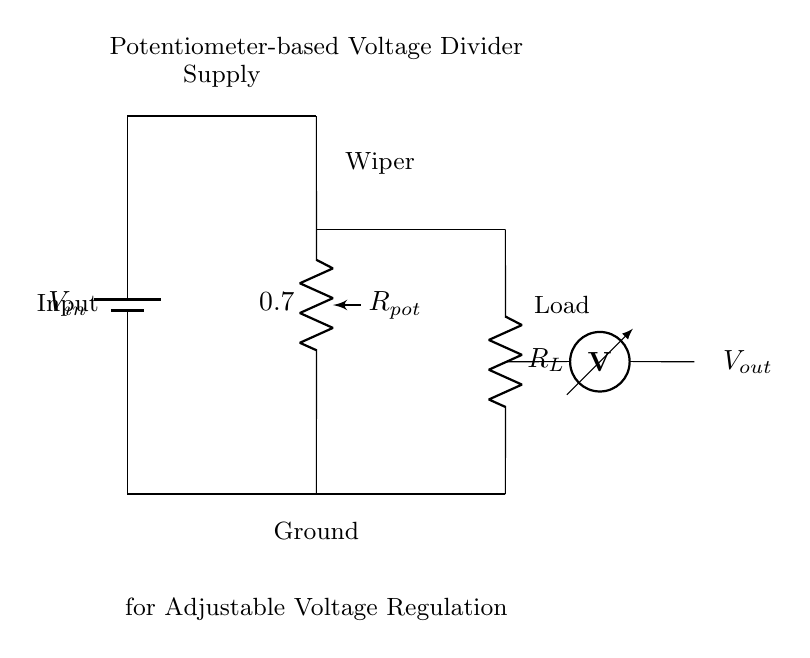What is the type of input in this circuit? The input in this circuit is a battery, indicated by the "battery1" symbol. It provides the voltage supply for the circuit.
Answer: Battery What is the purpose of the potentiometer in this circuit? The potentiometer is used as a variable resistor to adjust the voltage divided between its two ends, allowing for adjustable output voltage.
Answer: Adjustable voltage What is connected to the output of the circuit? The output of the circuit connects to a resistor labeled as "R_L", indicating it supplies voltage to a load.
Answer: R_L What happens to the output voltage if the potentiometer wiper is moved towards the top? Moving the wiper towards the top increases the output voltage as a greater portion of the input voltage appears across the load.
Answer: Increases What is the role of R_L in this circuit? R_L serves as the load resistance and it draws current from the voltage divider circuit, influencing the output voltage based on its value.
Answer: Load resistance What is the output voltage in relation to the input voltage? The output voltage is a fraction of the input voltage determined by the ratio of the potentiometer's resistance to the total resistance in the circuit.
Answer: Fraction What type of circuit is represented here? This is a voltage divider circuit specifically utilizing a potentiometer for adjustable voltage regulation.
Answer: Voltage divider 